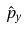Convert formula to latex. <formula><loc_0><loc_0><loc_500><loc_500>\hat { p } _ { y }</formula> 